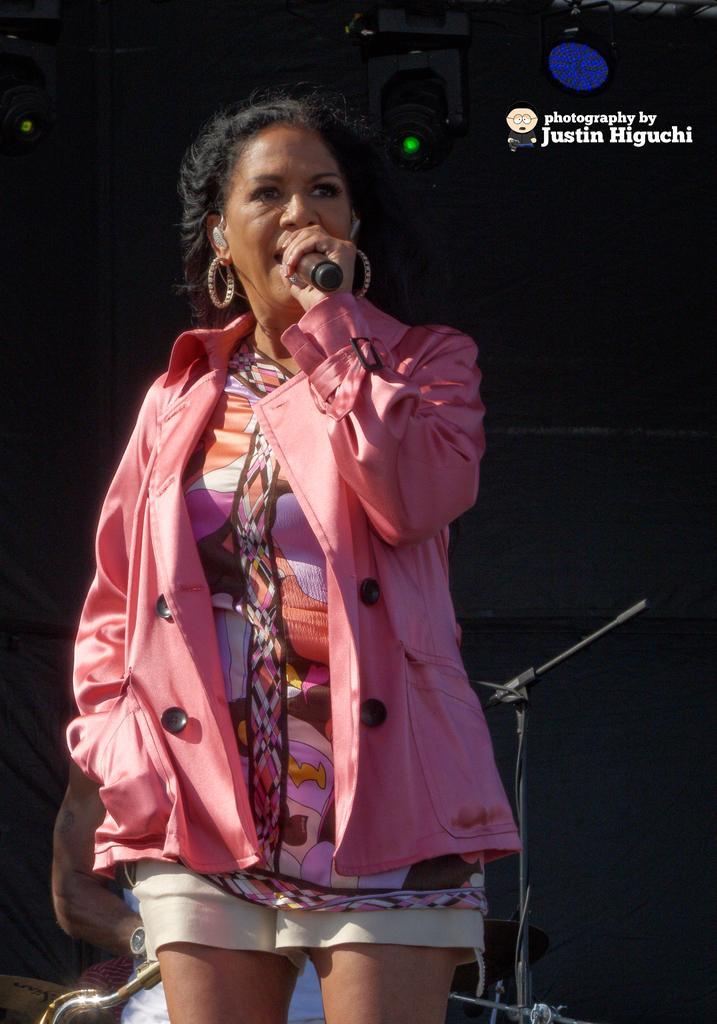Describe this image in one or two sentences. In this image i can see a woman wearing a pink jacket is standing and holding microphone in her hand. In the background i can see another person holding a musical instrument and few lights. 